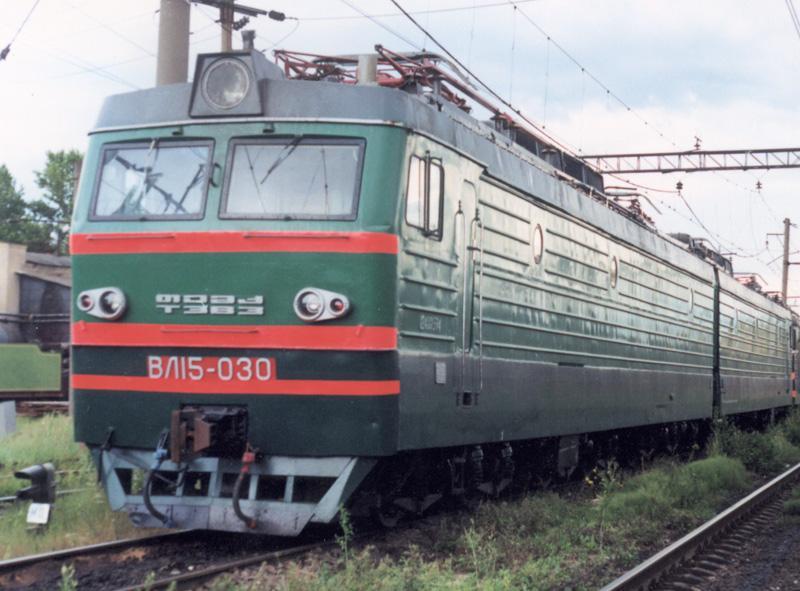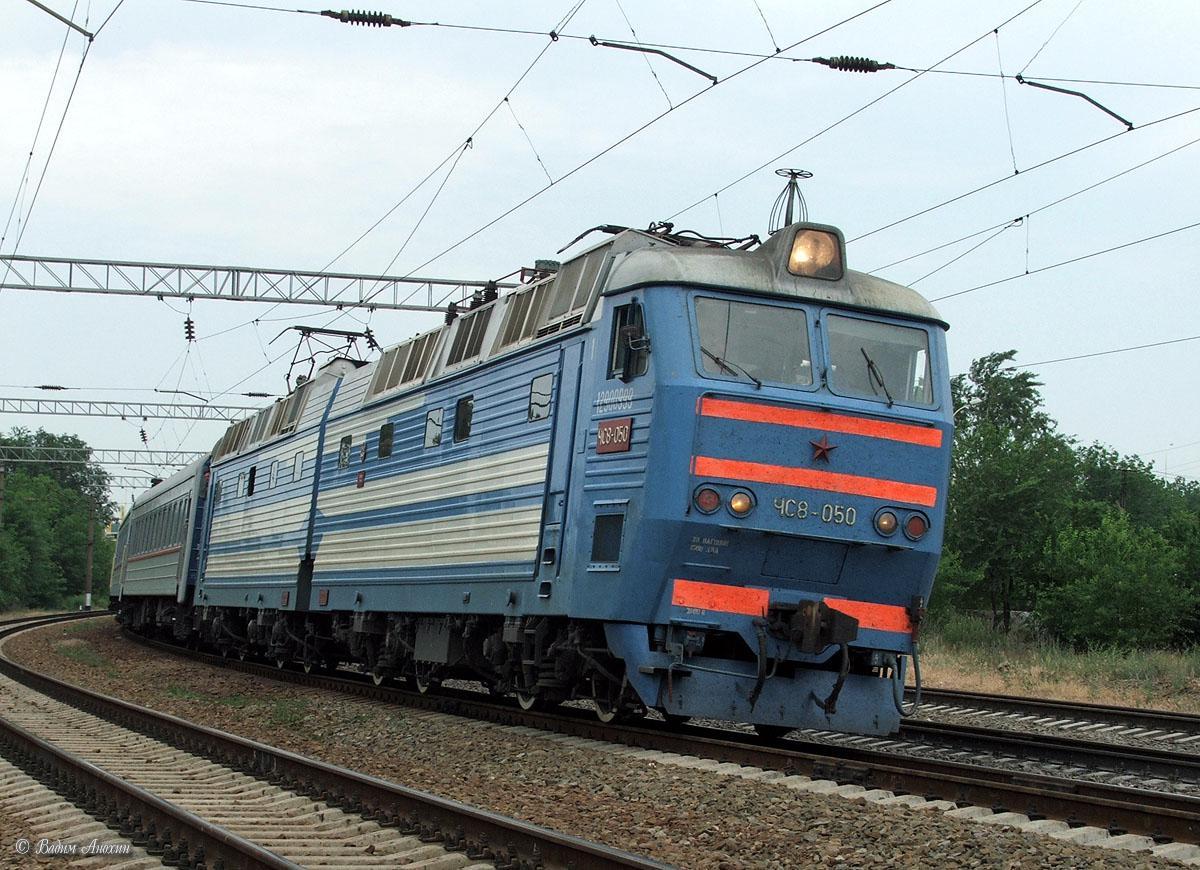The first image is the image on the left, the second image is the image on the right. Assess this claim about the two images: "There are three red stripes on the front of the train in the image on the left.". Correct or not? Answer yes or no. Yes. 